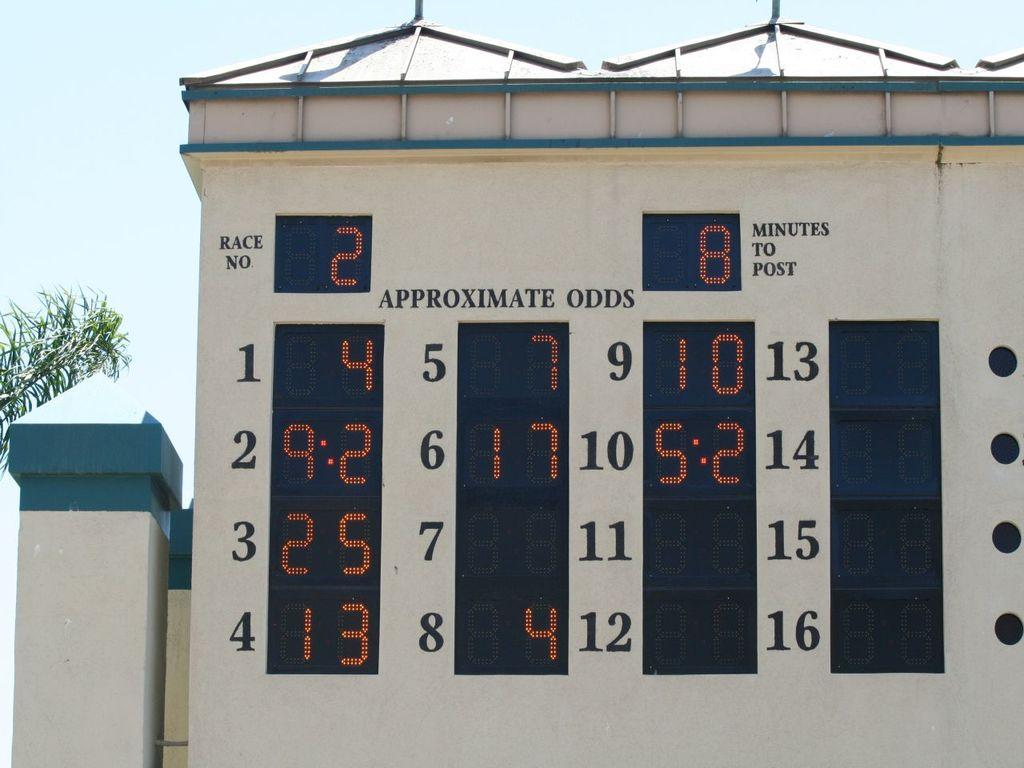<image>
Render a clear and concise summary of the photo. A digital board is lit up and labeled approximate odds. 